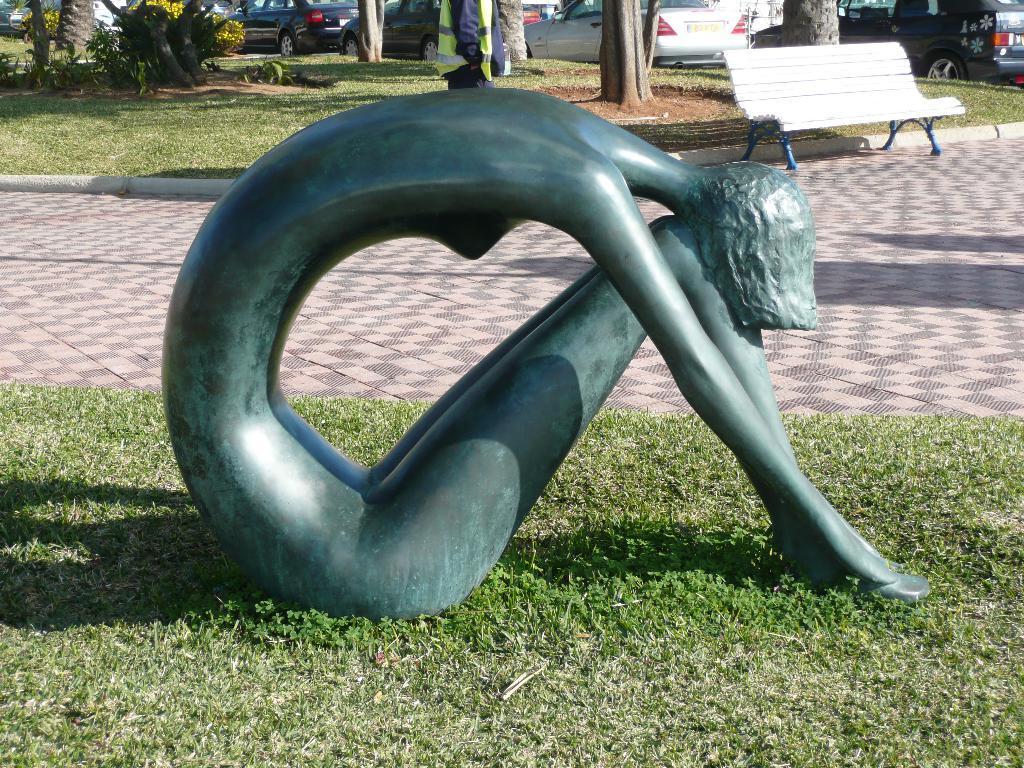Describe this image in one or two sentences. In the center of the image a statue is there. In the background of the image we can see grass, ground. At the top of the image we can see some trees, vehicles, person, bench, flowers. 